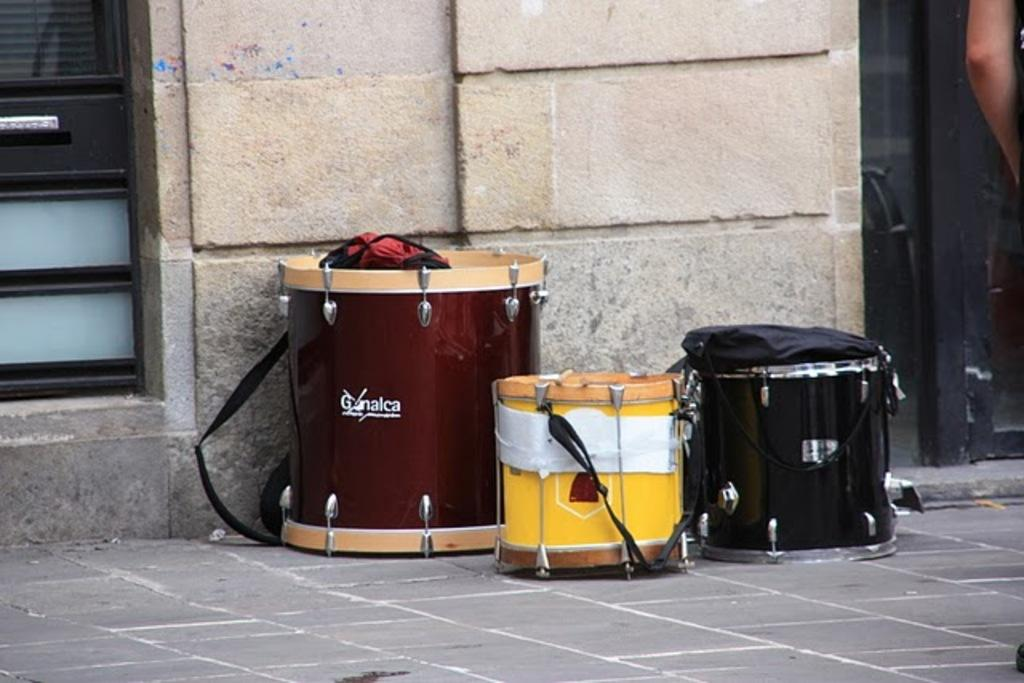<image>
Summarize the visual content of the image. A drum that has a brand name starting with G sits next to some other drums on the sidewalk. 